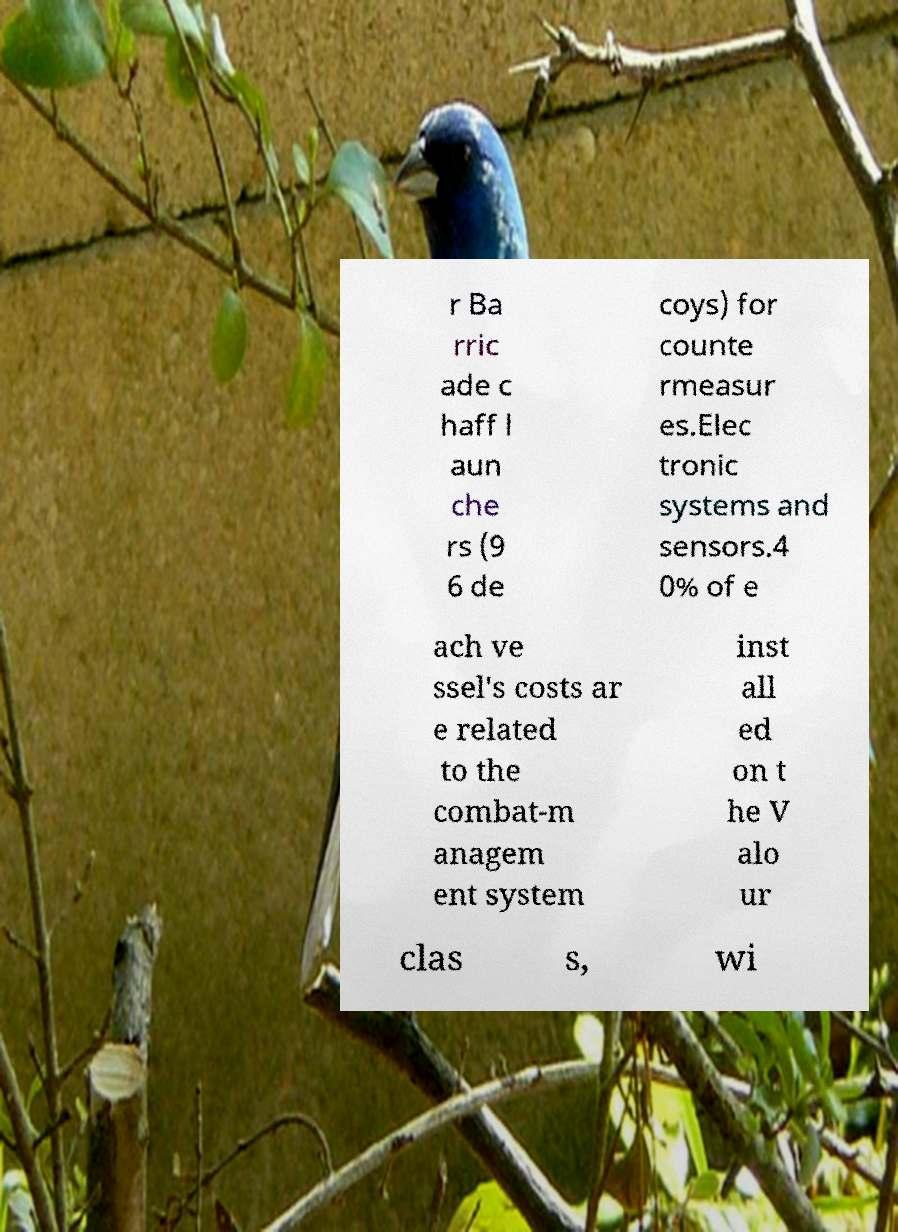There's text embedded in this image that I need extracted. Can you transcribe it verbatim? r Ba rric ade c haff l aun che rs (9 6 de coys) for counte rmeasur es.Elec tronic systems and sensors.4 0% of e ach ve ssel's costs ar e related to the combat-m anagem ent system inst all ed on t he V alo ur clas s, wi 